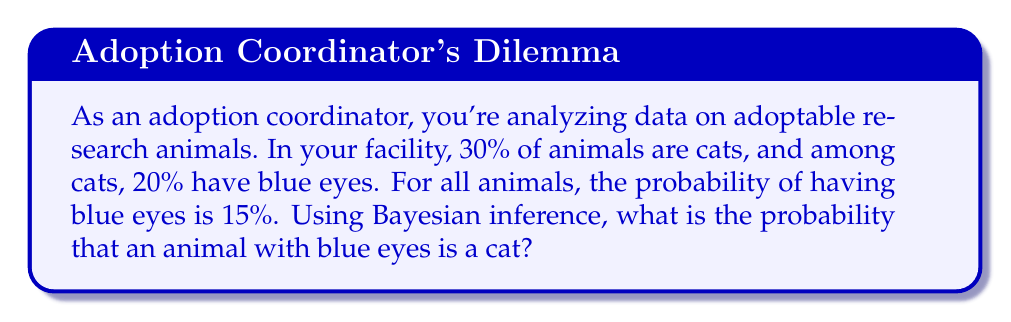Give your solution to this math problem. Let's approach this step-by-step using Bayes' theorem:

1) Define our events:
   A: The animal is a cat
   B: The animal has blue eyes

2) We're given the following probabilities:
   P(A) = 0.30 (30% of animals are cats)
   P(B|A) = 0.20 (20% of cats have blue eyes)
   P(B) = 0.15 (15% of all animals have blue eyes)

3) We want to find P(A|B), which is the probability that an animal is a cat given that it has blue eyes.

4) Bayes' theorem states:

   $$P(A|B) = \frac{P(B|A) \cdot P(A)}{P(B)}$$

5) Substituting our known values:

   $$P(A|B) = \frac{0.20 \cdot 0.30}{0.15}$$

6) Calculating:

   $$P(A|B) = \frac{0.06}{0.15} = 0.4$$

7) Converting to a percentage:

   0.4 * 100 = 40%

Therefore, the probability that an animal with blue eyes is a cat is 40%.
Answer: 40% 